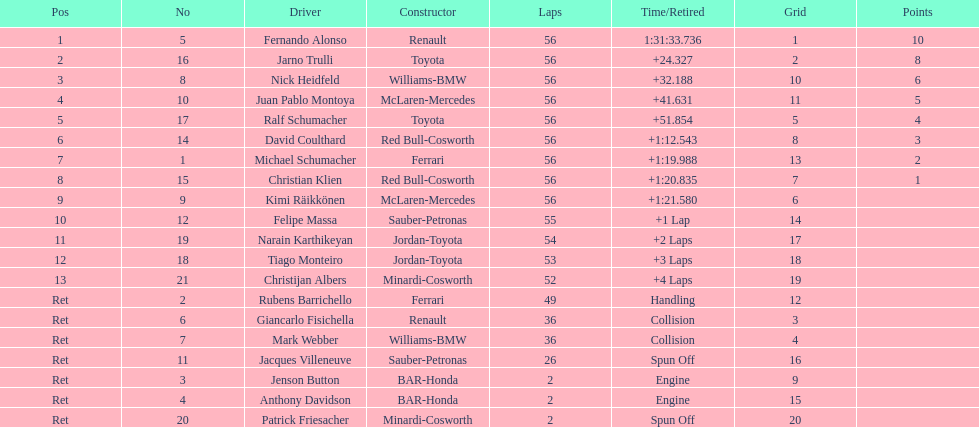How many bmws completed ahead of webber? 1. 